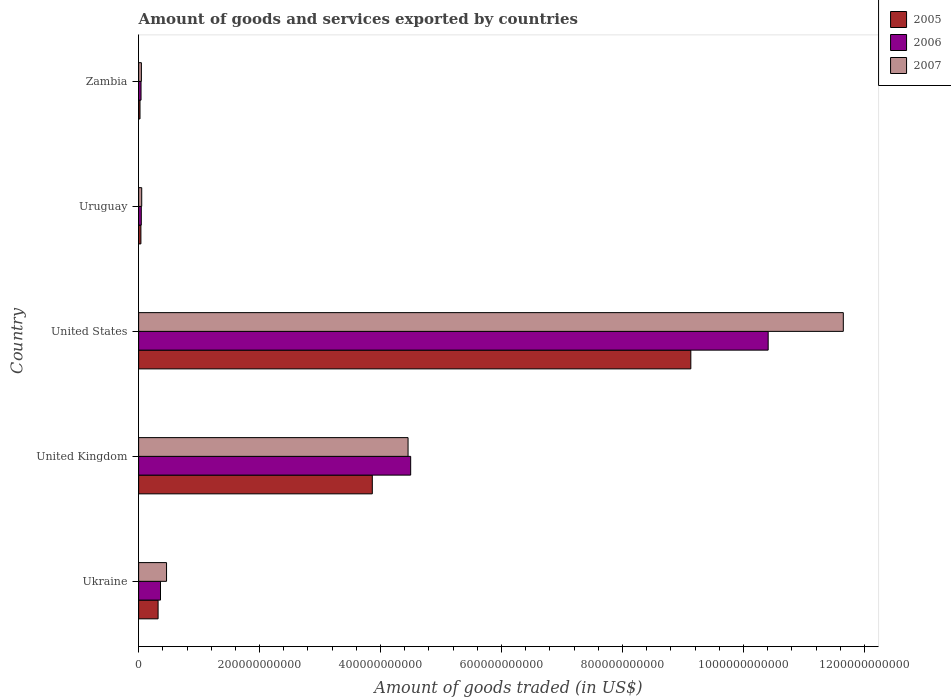How many bars are there on the 1st tick from the top?
Keep it short and to the point. 3. What is the label of the 1st group of bars from the top?
Your answer should be very brief. Zambia. What is the total amount of goods and services exported in 2005 in United States?
Offer a terse response. 9.13e+11. Across all countries, what is the maximum total amount of goods and services exported in 2007?
Your response must be concise. 1.17e+12. Across all countries, what is the minimum total amount of goods and services exported in 2005?
Provide a succinct answer. 2.28e+09. In which country was the total amount of goods and services exported in 2007 minimum?
Your answer should be compact. Zambia. What is the total total amount of goods and services exported in 2007 in the graph?
Make the answer very short. 1.67e+12. What is the difference between the total amount of goods and services exported in 2005 in Ukraine and that in Zambia?
Provide a short and direct response. 2.99e+1. What is the difference between the total amount of goods and services exported in 2007 in United Kingdom and the total amount of goods and services exported in 2006 in Ukraine?
Make the answer very short. 4.09e+11. What is the average total amount of goods and services exported in 2006 per country?
Make the answer very short. 3.07e+11. What is the difference between the total amount of goods and services exported in 2006 and total amount of goods and services exported in 2005 in United States?
Keep it short and to the point. 1.28e+11. In how many countries, is the total amount of goods and services exported in 2006 greater than 480000000000 US$?
Your answer should be compact. 1. What is the ratio of the total amount of goods and services exported in 2005 in United Kingdom to that in Uruguay?
Make the answer very short. 102.38. Is the total amount of goods and services exported in 2007 in Ukraine less than that in United States?
Provide a succinct answer. Yes. What is the difference between the highest and the second highest total amount of goods and services exported in 2005?
Offer a terse response. 5.27e+11. What is the difference between the highest and the lowest total amount of goods and services exported in 2005?
Keep it short and to the point. 9.11e+11. In how many countries, is the total amount of goods and services exported in 2007 greater than the average total amount of goods and services exported in 2007 taken over all countries?
Your response must be concise. 2. Is it the case that in every country, the sum of the total amount of goods and services exported in 2007 and total amount of goods and services exported in 2006 is greater than the total amount of goods and services exported in 2005?
Your answer should be compact. Yes. Are all the bars in the graph horizontal?
Provide a succinct answer. Yes. What is the difference between two consecutive major ticks on the X-axis?
Offer a terse response. 2.00e+11. Are the values on the major ticks of X-axis written in scientific E-notation?
Provide a succinct answer. No. Does the graph contain grids?
Your response must be concise. No. What is the title of the graph?
Your response must be concise. Amount of goods and services exported by countries. What is the label or title of the X-axis?
Provide a succinct answer. Amount of goods traded (in US$). What is the label or title of the Y-axis?
Your answer should be very brief. Country. What is the Amount of goods traded (in US$) of 2005 in Ukraine?
Provide a short and direct response. 3.22e+1. What is the Amount of goods traded (in US$) in 2006 in Ukraine?
Ensure brevity in your answer.  3.62e+1. What is the Amount of goods traded (in US$) in 2007 in Ukraine?
Offer a very short reply. 4.62e+1. What is the Amount of goods traded (in US$) in 2005 in United Kingdom?
Your answer should be very brief. 3.86e+11. What is the Amount of goods traded (in US$) of 2006 in United Kingdom?
Provide a succinct answer. 4.50e+11. What is the Amount of goods traded (in US$) in 2007 in United Kingdom?
Your answer should be very brief. 4.45e+11. What is the Amount of goods traded (in US$) of 2005 in United States?
Ensure brevity in your answer.  9.13e+11. What is the Amount of goods traded (in US$) of 2006 in United States?
Your answer should be compact. 1.04e+12. What is the Amount of goods traded (in US$) in 2007 in United States?
Provide a succinct answer. 1.17e+12. What is the Amount of goods traded (in US$) in 2005 in Uruguay?
Make the answer very short. 3.77e+09. What is the Amount of goods traded (in US$) of 2006 in Uruguay?
Offer a terse response. 4.40e+09. What is the Amount of goods traded (in US$) in 2007 in Uruguay?
Provide a succinct answer. 5.10e+09. What is the Amount of goods traded (in US$) in 2005 in Zambia?
Offer a very short reply. 2.28e+09. What is the Amount of goods traded (in US$) of 2006 in Zambia?
Provide a succinct answer. 3.98e+09. What is the Amount of goods traded (in US$) of 2007 in Zambia?
Keep it short and to the point. 4.56e+09. Across all countries, what is the maximum Amount of goods traded (in US$) of 2005?
Keep it short and to the point. 9.13e+11. Across all countries, what is the maximum Amount of goods traded (in US$) of 2006?
Your answer should be very brief. 1.04e+12. Across all countries, what is the maximum Amount of goods traded (in US$) in 2007?
Keep it short and to the point. 1.17e+12. Across all countries, what is the minimum Amount of goods traded (in US$) in 2005?
Make the answer very short. 2.28e+09. Across all countries, what is the minimum Amount of goods traded (in US$) of 2006?
Your answer should be compact. 3.98e+09. Across all countries, what is the minimum Amount of goods traded (in US$) of 2007?
Your answer should be compact. 4.56e+09. What is the total Amount of goods traded (in US$) in 2005 in the graph?
Make the answer very short. 1.34e+12. What is the total Amount of goods traded (in US$) in 2006 in the graph?
Your answer should be very brief. 1.54e+12. What is the total Amount of goods traded (in US$) in 2007 in the graph?
Offer a terse response. 1.67e+12. What is the difference between the Amount of goods traded (in US$) of 2005 in Ukraine and that in United Kingdom?
Make the answer very short. -3.54e+11. What is the difference between the Amount of goods traded (in US$) of 2006 in Ukraine and that in United Kingdom?
Provide a succinct answer. -4.14e+11. What is the difference between the Amount of goods traded (in US$) in 2007 in Ukraine and that in United Kingdom?
Offer a terse response. -3.99e+11. What is the difference between the Amount of goods traded (in US$) in 2005 in Ukraine and that in United States?
Provide a succinct answer. -8.81e+11. What is the difference between the Amount of goods traded (in US$) in 2006 in Ukraine and that in United States?
Offer a terse response. -1.00e+12. What is the difference between the Amount of goods traded (in US$) in 2007 in Ukraine and that in United States?
Your response must be concise. -1.12e+12. What is the difference between the Amount of goods traded (in US$) in 2005 in Ukraine and that in Uruguay?
Make the answer very short. 2.84e+1. What is the difference between the Amount of goods traded (in US$) of 2006 in Ukraine and that in Uruguay?
Your answer should be compact. 3.18e+1. What is the difference between the Amount of goods traded (in US$) in 2007 in Ukraine and that in Uruguay?
Keep it short and to the point. 4.11e+1. What is the difference between the Amount of goods traded (in US$) in 2005 in Ukraine and that in Zambia?
Your response must be concise. 2.99e+1. What is the difference between the Amount of goods traded (in US$) in 2006 in Ukraine and that in Zambia?
Offer a terse response. 3.22e+1. What is the difference between the Amount of goods traded (in US$) in 2007 in Ukraine and that in Zambia?
Offer a very short reply. 4.16e+1. What is the difference between the Amount of goods traded (in US$) of 2005 in United Kingdom and that in United States?
Provide a succinct answer. -5.27e+11. What is the difference between the Amount of goods traded (in US$) in 2006 in United Kingdom and that in United States?
Your answer should be very brief. -5.91e+11. What is the difference between the Amount of goods traded (in US$) of 2007 in United Kingdom and that in United States?
Give a very brief answer. -7.20e+11. What is the difference between the Amount of goods traded (in US$) in 2005 in United Kingdom and that in Uruguay?
Provide a succinct answer. 3.83e+11. What is the difference between the Amount of goods traded (in US$) in 2006 in United Kingdom and that in Uruguay?
Keep it short and to the point. 4.45e+11. What is the difference between the Amount of goods traded (in US$) in 2007 in United Kingdom and that in Uruguay?
Your answer should be very brief. 4.40e+11. What is the difference between the Amount of goods traded (in US$) in 2005 in United Kingdom and that in Zambia?
Provide a succinct answer. 3.84e+11. What is the difference between the Amount of goods traded (in US$) in 2006 in United Kingdom and that in Zambia?
Your answer should be compact. 4.46e+11. What is the difference between the Amount of goods traded (in US$) in 2007 in United Kingdom and that in Zambia?
Your answer should be very brief. 4.41e+11. What is the difference between the Amount of goods traded (in US$) of 2005 in United States and that in Uruguay?
Your response must be concise. 9.09e+11. What is the difference between the Amount of goods traded (in US$) of 2006 in United States and that in Uruguay?
Provide a succinct answer. 1.04e+12. What is the difference between the Amount of goods traded (in US$) of 2007 in United States and that in Uruguay?
Offer a terse response. 1.16e+12. What is the difference between the Amount of goods traded (in US$) in 2005 in United States and that in Zambia?
Give a very brief answer. 9.11e+11. What is the difference between the Amount of goods traded (in US$) in 2006 in United States and that in Zambia?
Ensure brevity in your answer.  1.04e+12. What is the difference between the Amount of goods traded (in US$) in 2007 in United States and that in Zambia?
Your answer should be compact. 1.16e+12. What is the difference between the Amount of goods traded (in US$) in 2005 in Uruguay and that in Zambia?
Offer a terse response. 1.50e+09. What is the difference between the Amount of goods traded (in US$) of 2006 in Uruguay and that in Zambia?
Make the answer very short. 4.15e+08. What is the difference between the Amount of goods traded (in US$) of 2007 in Uruguay and that in Zambia?
Ensure brevity in your answer.  5.44e+08. What is the difference between the Amount of goods traded (in US$) in 2005 in Ukraine and the Amount of goods traded (in US$) in 2006 in United Kingdom?
Provide a succinct answer. -4.18e+11. What is the difference between the Amount of goods traded (in US$) of 2005 in Ukraine and the Amount of goods traded (in US$) of 2007 in United Kingdom?
Ensure brevity in your answer.  -4.13e+11. What is the difference between the Amount of goods traded (in US$) of 2006 in Ukraine and the Amount of goods traded (in US$) of 2007 in United Kingdom?
Your response must be concise. -4.09e+11. What is the difference between the Amount of goods traded (in US$) in 2005 in Ukraine and the Amount of goods traded (in US$) in 2006 in United States?
Your response must be concise. -1.01e+12. What is the difference between the Amount of goods traded (in US$) in 2005 in Ukraine and the Amount of goods traded (in US$) in 2007 in United States?
Your answer should be very brief. -1.13e+12. What is the difference between the Amount of goods traded (in US$) in 2006 in Ukraine and the Amount of goods traded (in US$) in 2007 in United States?
Your answer should be compact. -1.13e+12. What is the difference between the Amount of goods traded (in US$) of 2005 in Ukraine and the Amount of goods traded (in US$) of 2006 in Uruguay?
Ensure brevity in your answer.  2.78e+1. What is the difference between the Amount of goods traded (in US$) in 2005 in Ukraine and the Amount of goods traded (in US$) in 2007 in Uruguay?
Give a very brief answer. 2.71e+1. What is the difference between the Amount of goods traded (in US$) of 2006 in Ukraine and the Amount of goods traded (in US$) of 2007 in Uruguay?
Keep it short and to the point. 3.11e+1. What is the difference between the Amount of goods traded (in US$) of 2005 in Ukraine and the Amount of goods traded (in US$) of 2006 in Zambia?
Offer a terse response. 2.82e+1. What is the difference between the Amount of goods traded (in US$) of 2005 in Ukraine and the Amount of goods traded (in US$) of 2007 in Zambia?
Give a very brief answer. 2.76e+1. What is the difference between the Amount of goods traded (in US$) in 2006 in Ukraine and the Amount of goods traded (in US$) in 2007 in Zambia?
Your answer should be very brief. 3.16e+1. What is the difference between the Amount of goods traded (in US$) in 2005 in United Kingdom and the Amount of goods traded (in US$) in 2006 in United States?
Give a very brief answer. -6.55e+11. What is the difference between the Amount of goods traded (in US$) of 2005 in United Kingdom and the Amount of goods traded (in US$) of 2007 in United States?
Offer a terse response. -7.79e+11. What is the difference between the Amount of goods traded (in US$) in 2006 in United Kingdom and the Amount of goods traded (in US$) in 2007 in United States?
Offer a very short reply. -7.15e+11. What is the difference between the Amount of goods traded (in US$) in 2005 in United Kingdom and the Amount of goods traded (in US$) in 2006 in Uruguay?
Provide a short and direct response. 3.82e+11. What is the difference between the Amount of goods traded (in US$) of 2005 in United Kingdom and the Amount of goods traded (in US$) of 2007 in Uruguay?
Give a very brief answer. 3.81e+11. What is the difference between the Amount of goods traded (in US$) of 2006 in United Kingdom and the Amount of goods traded (in US$) of 2007 in Uruguay?
Offer a very short reply. 4.45e+11. What is the difference between the Amount of goods traded (in US$) of 2005 in United Kingdom and the Amount of goods traded (in US$) of 2006 in Zambia?
Offer a very short reply. 3.82e+11. What is the difference between the Amount of goods traded (in US$) in 2005 in United Kingdom and the Amount of goods traded (in US$) in 2007 in Zambia?
Make the answer very short. 3.82e+11. What is the difference between the Amount of goods traded (in US$) of 2006 in United Kingdom and the Amount of goods traded (in US$) of 2007 in Zambia?
Your answer should be very brief. 4.45e+11. What is the difference between the Amount of goods traded (in US$) of 2005 in United States and the Amount of goods traded (in US$) of 2006 in Uruguay?
Offer a very short reply. 9.09e+11. What is the difference between the Amount of goods traded (in US$) of 2005 in United States and the Amount of goods traded (in US$) of 2007 in Uruguay?
Make the answer very short. 9.08e+11. What is the difference between the Amount of goods traded (in US$) in 2006 in United States and the Amount of goods traded (in US$) in 2007 in Uruguay?
Keep it short and to the point. 1.04e+12. What is the difference between the Amount of goods traded (in US$) in 2005 in United States and the Amount of goods traded (in US$) in 2006 in Zambia?
Ensure brevity in your answer.  9.09e+11. What is the difference between the Amount of goods traded (in US$) in 2005 in United States and the Amount of goods traded (in US$) in 2007 in Zambia?
Offer a very short reply. 9.08e+11. What is the difference between the Amount of goods traded (in US$) in 2006 in United States and the Amount of goods traded (in US$) in 2007 in Zambia?
Your answer should be compact. 1.04e+12. What is the difference between the Amount of goods traded (in US$) of 2005 in Uruguay and the Amount of goods traded (in US$) of 2006 in Zambia?
Your answer should be very brief. -2.11e+08. What is the difference between the Amount of goods traded (in US$) in 2005 in Uruguay and the Amount of goods traded (in US$) in 2007 in Zambia?
Provide a short and direct response. -7.82e+08. What is the difference between the Amount of goods traded (in US$) of 2006 in Uruguay and the Amount of goods traded (in US$) of 2007 in Zambia?
Your answer should be very brief. -1.56e+08. What is the average Amount of goods traded (in US$) in 2005 per country?
Your answer should be compact. 2.68e+11. What is the average Amount of goods traded (in US$) of 2006 per country?
Ensure brevity in your answer.  3.07e+11. What is the average Amount of goods traded (in US$) in 2007 per country?
Your answer should be very brief. 3.33e+11. What is the difference between the Amount of goods traded (in US$) in 2005 and Amount of goods traded (in US$) in 2006 in Ukraine?
Provide a short and direct response. -3.99e+09. What is the difference between the Amount of goods traded (in US$) of 2005 and Amount of goods traded (in US$) of 2007 in Ukraine?
Ensure brevity in your answer.  -1.40e+1. What is the difference between the Amount of goods traded (in US$) in 2006 and Amount of goods traded (in US$) in 2007 in Ukraine?
Provide a succinct answer. -9.99e+09. What is the difference between the Amount of goods traded (in US$) of 2005 and Amount of goods traded (in US$) of 2006 in United Kingdom?
Ensure brevity in your answer.  -6.34e+1. What is the difference between the Amount of goods traded (in US$) in 2005 and Amount of goods traded (in US$) in 2007 in United Kingdom?
Provide a short and direct response. -5.91e+1. What is the difference between the Amount of goods traded (in US$) of 2006 and Amount of goods traded (in US$) of 2007 in United Kingdom?
Offer a very short reply. 4.31e+09. What is the difference between the Amount of goods traded (in US$) in 2005 and Amount of goods traded (in US$) in 2006 in United States?
Keep it short and to the point. -1.28e+11. What is the difference between the Amount of goods traded (in US$) of 2005 and Amount of goods traded (in US$) of 2007 in United States?
Make the answer very short. -2.52e+11. What is the difference between the Amount of goods traded (in US$) in 2006 and Amount of goods traded (in US$) in 2007 in United States?
Make the answer very short. -1.24e+11. What is the difference between the Amount of goods traded (in US$) in 2005 and Amount of goods traded (in US$) in 2006 in Uruguay?
Provide a short and direct response. -6.26e+08. What is the difference between the Amount of goods traded (in US$) in 2005 and Amount of goods traded (in US$) in 2007 in Uruguay?
Offer a terse response. -1.33e+09. What is the difference between the Amount of goods traded (in US$) of 2006 and Amount of goods traded (in US$) of 2007 in Uruguay?
Your response must be concise. -7.00e+08. What is the difference between the Amount of goods traded (in US$) in 2005 and Amount of goods traded (in US$) in 2006 in Zambia?
Keep it short and to the point. -1.71e+09. What is the difference between the Amount of goods traded (in US$) of 2005 and Amount of goods traded (in US$) of 2007 in Zambia?
Provide a succinct answer. -2.28e+09. What is the difference between the Amount of goods traded (in US$) in 2006 and Amount of goods traded (in US$) in 2007 in Zambia?
Make the answer very short. -5.71e+08. What is the ratio of the Amount of goods traded (in US$) in 2005 in Ukraine to that in United Kingdom?
Offer a very short reply. 0.08. What is the ratio of the Amount of goods traded (in US$) of 2006 in Ukraine to that in United Kingdom?
Your answer should be very brief. 0.08. What is the ratio of the Amount of goods traded (in US$) in 2007 in Ukraine to that in United Kingdom?
Provide a short and direct response. 0.1. What is the ratio of the Amount of goods traded (in US$) in 2005 in Ukraine to that in United States?
Offer a terse response. 0.04. What is the ratio of the Amount of goods traded (in US$) of 2006 in Ukraine to that in United States?
Offer a very short reply. 0.03. What is the ratio of the Amount of goods traded (in US$) of 2007 in Ukraine to that in United States?
Keep it short and to the point. 0.04. What is the ratio of the Amount of goods traded (in US$) of 2005 in Ukraine to that in Uruguay?
Make the answer very short. 8.53. What is the ratio of the Amount of goods traded (in US$) in 2006 in Ukraine to that in Uruguay?
Give a very brief answer. 8.22. What is the ratio of the Amount of goods traded (in US$) of 2007 in Ukraine to that in Uruguay?
Give a very brief answer. 9.05. What is the ratio of the Amount of goods traded (in US$) of 2005 in Ukraine to that in Zambia?
Provide a succinct answer. 14.13. What is the ratio of the Amount of goods traded (in US$) of 2006 in Ukraine to that in Zambia?
Offer a very short reply. 9.08. What is the ratio of the Amount of goods traded (in US$) of 2007 in Ukraine to that in Zambia?
Offer a terse response. 10.13. What is the ratio of the Amount of goods traded (in US$) in 2005 in United Kingdom to that in United States?
Your answer should be compact. 0.42. What is the ratio of the Amount of goods traded (in US$) in 2006 in United Kingdom to that in United States?
Provide a succinct answer. 0.43. What is the ratio of the Amount of goods traded (in US$) in 2007 in United Kingdom to that in United States?
Provide a short and direct response. 0.38. What is the ratio of the Amount of goods traded (in US$) in 2005 in United Kingdom to that in Uruguay?
Keep it short and to the point. 102.38. What is the ratio of the Amount of goods traded (in US$) of 2006 in United Kingdom to that in Uruguay?
Your answer should be compact. 102.23. What is the ratio of the Amount of goods traded (in US$) in 2007 in United Kingdom to that in Uruguay?
Your answer should be compact. 87.35. What is the ratio of the Amount of goods traded (in US$) of 2005 in United Kingdom to that in Zambia?
Your response must be concise. 169.6. What is the ratio of the Amount of goods traded (in US$) of 2006 in United Kingdom to that in Zambia?
Your answer should be very brief. 112.88. What is the ratio of the Amount of goods traded (in US$) of 2007 in United Kingdom to that in Zambia?
Offer a very short reply. 97.79. What is the ratio of the Amount of goods traded (in US$) of 2005 in United States to that in Uruguay?
Give a very brief answer. 241.92. What is the ratio of the Amount of goods traded (in US$) of 2006 in United States to that in Uruguay?
Give a very brief answer. 236.58. What is the ratio of the Amount of goods traded (in US$) of 2007 in United States to that in Uruguay?
Keep it short and to the point. 228.47. What is the ratio of the Amount of goods traded (in US$) in 2005 in United States to that in Zambia?
Make the answer very short. 400.76. What is the ratio of the Amount of goods traded (in US$) of 2006 in United States to that in Zambia?
Ensure brevity in your answer.  261.22. What is the ratio of the Amount of goods traded (in US$) in 2007 in United States to that in Zambia?
Your response must be concise. 255.76. What is the ratio of the Amount of goods traded (in US$) of 2005 in Uruguay to that in Zambia?
Provide a short and direct response. 1.66. What is the ratio of the Amount of goods traded (in US$) in 2006 in Uruguay to that in Zambia?
Your response must be concise. 1.1. What is the ratio of the Amount of goods traded (in US$) of 2007 in Uruguay to that in Zambia?
Your answer should be compact. 1.12. What is the difference between the highest and the second highest Amount of goods traded (in US$) of 2005?
Give a very brief answer. 5.27e+11. What is the difference between the highest and the second highest Amount of goods traded (in US$) in 2006?
Offer a very short reply. 5.91e+11. What is the difference between the highest and the second highest Amount of goods traded (in US$) in 2007?
Your answer should be very brief. 7.20e+11. What is the difference between the highest and the lowest Amount of goods traded (in US$) of 2005?
Give a very brief answer. 9.11e+11. What is the difference between the highest and the lowest Amount of goods traded (in US$) in 2006?
Your answer should be compact. 1.04e+12. What is the difference between the highest and the lowest Amount of goods traded (in US$) of 2007?
Give a very brief answer. 1.16e+12. 